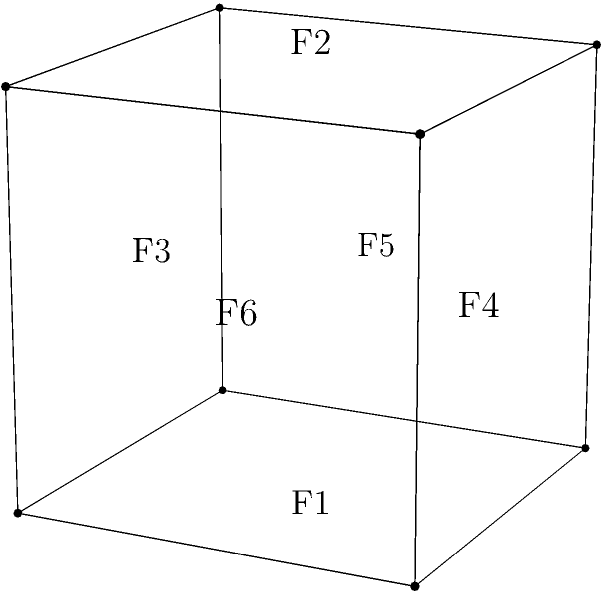As a doctoral candidate studying bacterial pathogenesis, you're likely familiar with the concept of topology in biological structures. Consider a cube-shaped bacterial inclusion body within a host cell. If we model this inclusion as a polyhedron with 6 faces (F), 12 edges (E), and 8 vertices (V), what is its Euler characteristic (χ)? How does this relate to the general formula for the Euler characteristic of a polyhedron? Let's approach this step-by-step:

1) The Euler characteristic (χ) is a topological invariant that describes the structure of a topological space regardless of how it is bent or stretched. For polyhedra, it is calculated using the formula:

   $$χ = V - E + F$$

   Where:
   V = number of vertices
   E = number of edges
   F = number of faces

2) For our cube-shaped bacterial inclusion body, we are given:
   F = 6 (faces)
   E = 12 (edges)
   V = 8 (vertices)

3) Let's substitute these values into the Euler characteristic formula:

   $$χ = V - E + F$$
   $$χ = 8 - 12 + 6$$
   $$χ = 2$$

4) This result, χ = 2, is not coincidental. It's a fundamental property of all convex polyhedra, including our cube-shaped inclusion body.

5) In fact, for any simply connected polyhedron (i.e., a polyhedron with no holes), the Euler characteristic will always be 2, regardless of the number of faces, edges, or vertices.

6) This concept extends beyond simple shapes and into more complex topological structures, including those found in bacterial cell walls and membrane proteins, where understanding the topology can be crucial for comprehending function and interactions.

7) In the context of bacterial pathogenesis, this topological invariance could be relevant when studying the structure of bacterial inclusion bodies, the organization of bacterial cell wall components, or the arrangement of virulence factors on the bacterial surface.
Answer: χ = 2 